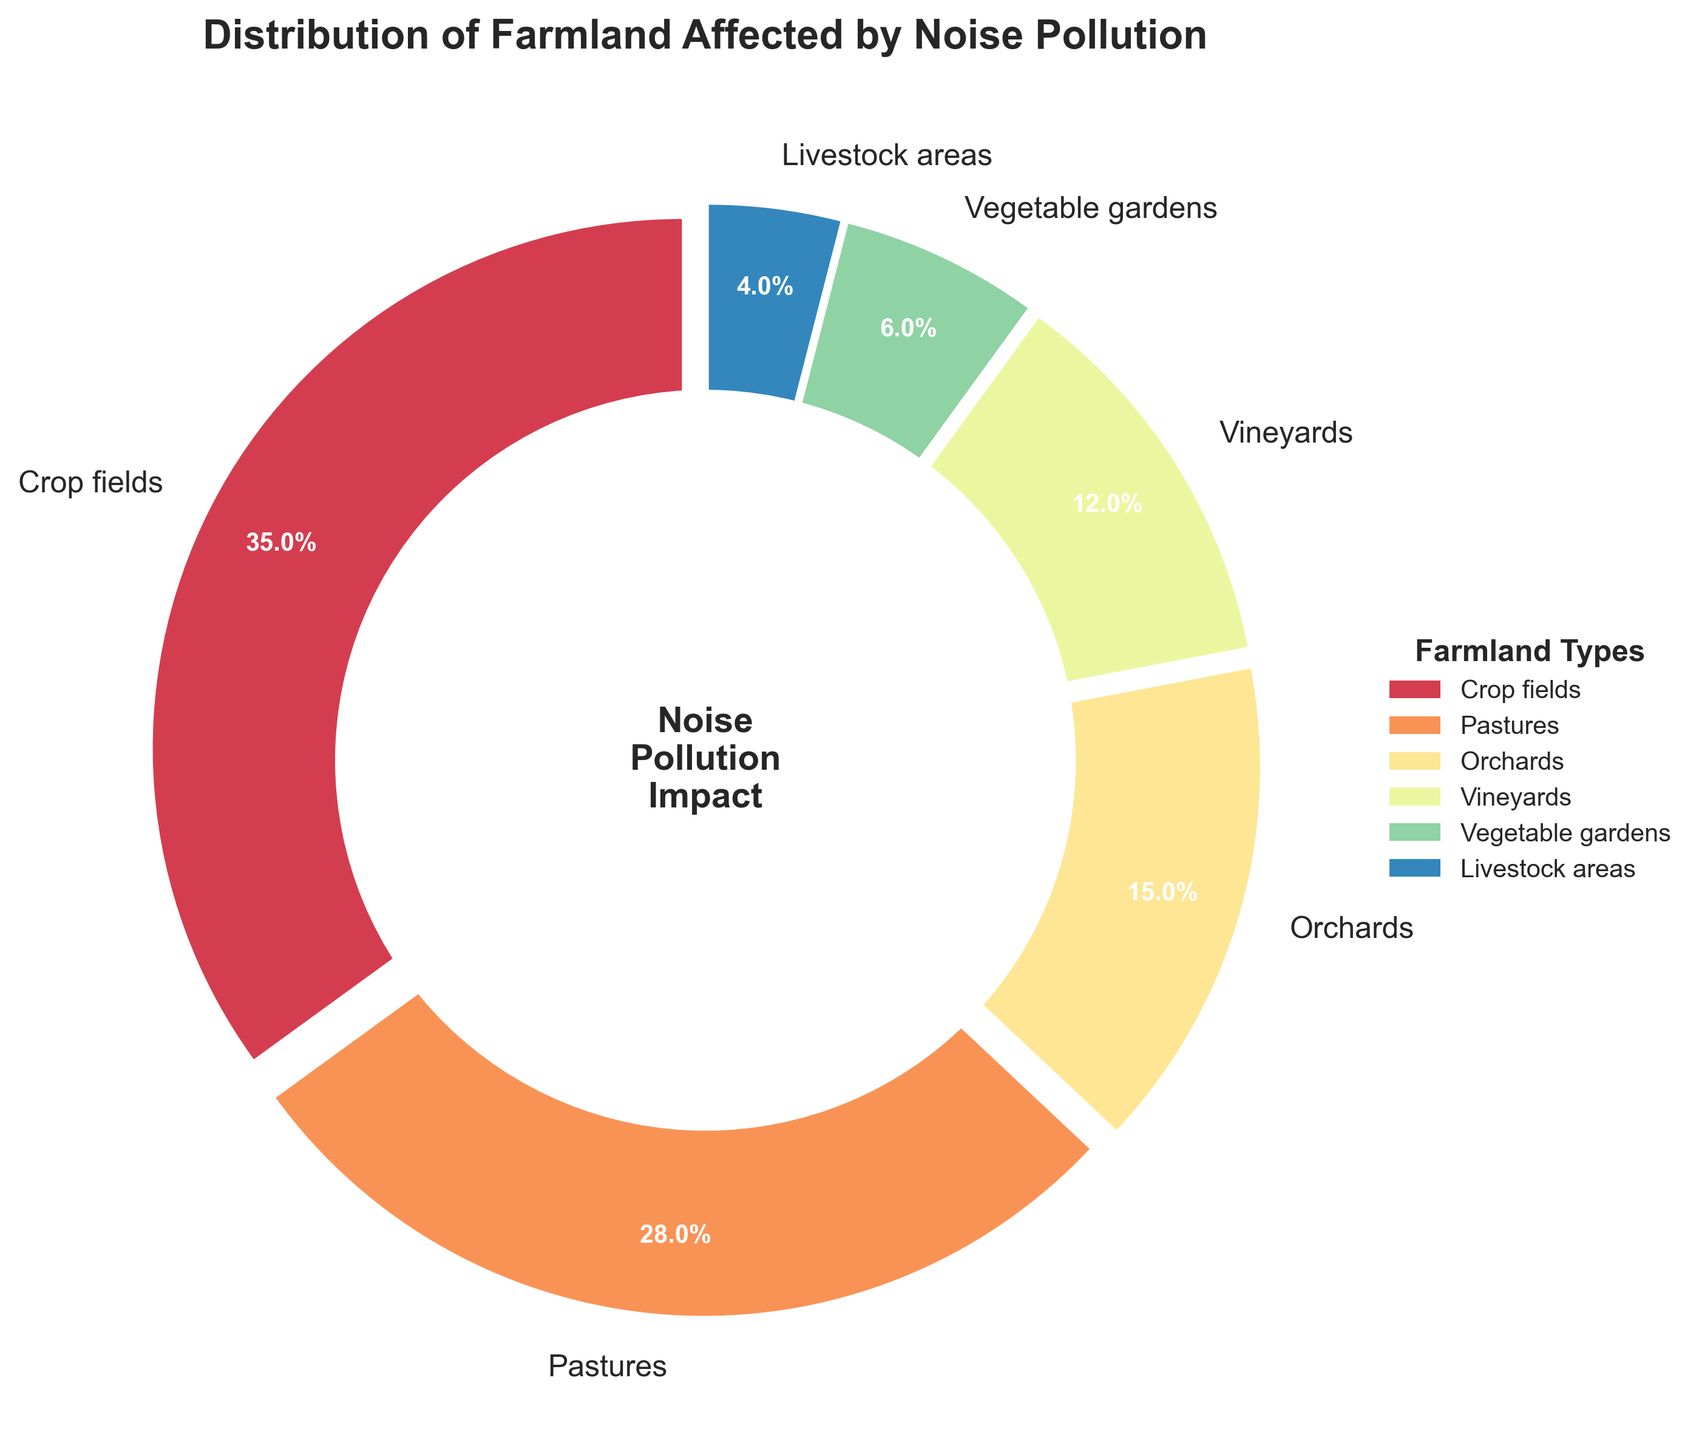What type of farmland is most affected by noise pollution? The crop fields have the largest section in the pie chart, making up 35% of the farmland affected by noise pollution.
Answer: Crop fields Which farmland type is more affected by noise pollution, pastures or vineyards? By looking at the percentages, pastures (28%) are more affected than vineyards (12%).
Answer: Pastures What is the combined percentage of noise pollution impact on orchards and vegetable gardens? The orchard piece of the pie chart indicates 15%, and the vegetable garden piece shows 6%. Adding these gives 15% + 6% = 21%.
Answer: 21% By how much is the noise pollution impact on livestock areas lower compared to pastures? The pie chart shows livestock areas at 4% and pastures at 28%. The difference is 28% - 4% = 24%.
Answer: 24% Which farmland types have a lower percentage of noise pollution impact than vineyards? From the pie chart, the types with percentages lower than 12% (vineyards) are vegetable gardens (6%) and livestock areas (4%).
Answer: Vegetable gardens, Livestock areas Among crop fields, pastures, and orchards, which two have the highest combined percentage of noise pollution impact? Crop fields are at 35%, pastures at 28%, and orchards at 15%. Combining crop fields and pastures gives 63%, which is higher than any other combination.
Answer: Crop fields and pastures If another farmland type with a 10% noise pollution impact were added, what would be the new total percentage for crop fields, pastures, and the new type combined? Adding the new 10% to crop fields (35%) and pastures (28%) yields 35% + 28% + 10% = 73%.
Answer: 73% What visual attribute does the pie chart use to indicate the impact of noise pollution? The pie chart uses different sizes of pie slices, with larger slices representing higher percentages of noise pollution impact.
Answer: Sizes of pie slices If you combine the noise pollution impact percentages of livestock areas and vegetable gardens, how does that compare to the impact on orchards? Livestock areas (4%) plus vegetable gardens (6%) equals 10%, which is less than the 15% impact on orchards.
Answer: Less Ranking the farmland types by the percentage affected by noise pollution from highest to lowest, what is the correct order? The order based on the pie chart is: Crop fields (35%), Pastures (28%), Orchards (15%), Vineyards (12%), Vegetable gardens (6%), Livestock areas (4%).
Answer: Crop fields, Pastures, Orchards, Vineyards, Vegetable gardens, Livestock areas 